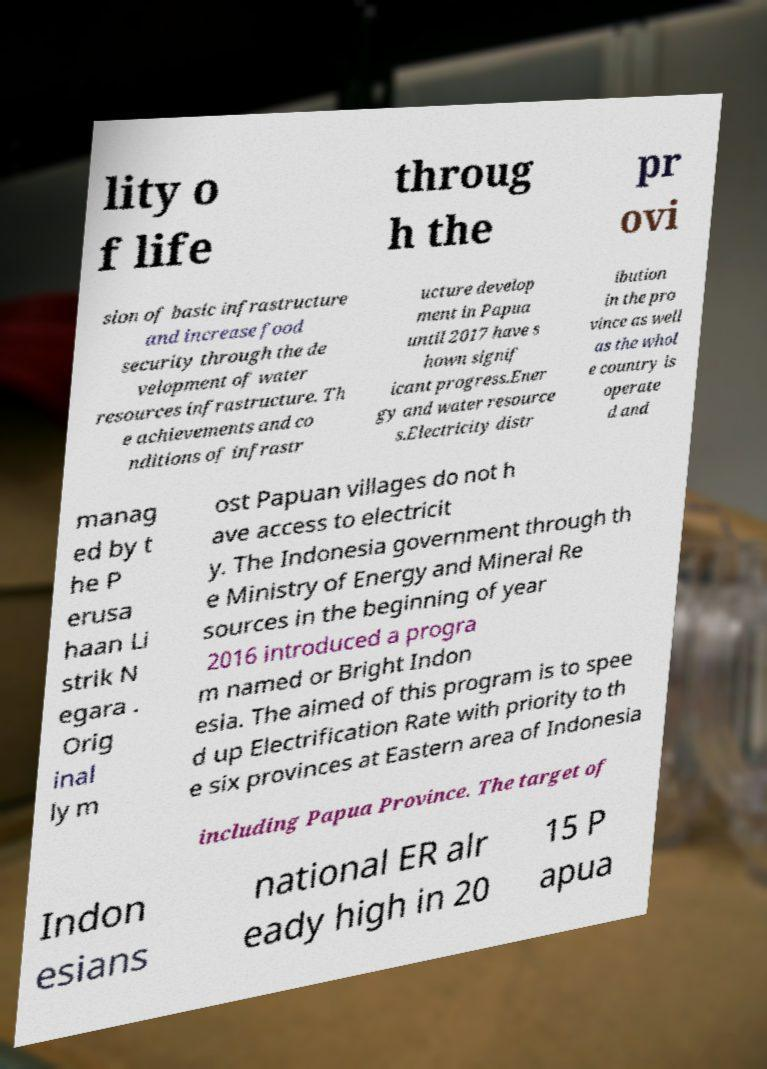I need the written content from this picture converted into text. Can you do that? lity o f life throug h the pr ovi sion of basic infrastructure and increase food security through the de velopment of water resources infrastructure. Th e achievements and co nditions of infrastr ucture develop ment in Papua until 2017 have s hown signif icant progress.Ener gy and water resource s.Electricity distr ibution in the pro vince as well as the whol e country is operate d and manag ed by t he P erusa haan Li strik N egara . Orig inal ly m ost Papuan villages do not h ave access to electricit y. The Indonesia government through th e Ministry of Energy and Mineral Re sources in the beginning of year 2016 introduced a progra m named or Bright Indon esia. The aimed of this program is to spee d up Electrification Rate with priority to th e six provinces at Eastern area of Indonesia including Papua Province. The target of Indon esians national ER alr eady high in 20 15 P apua 